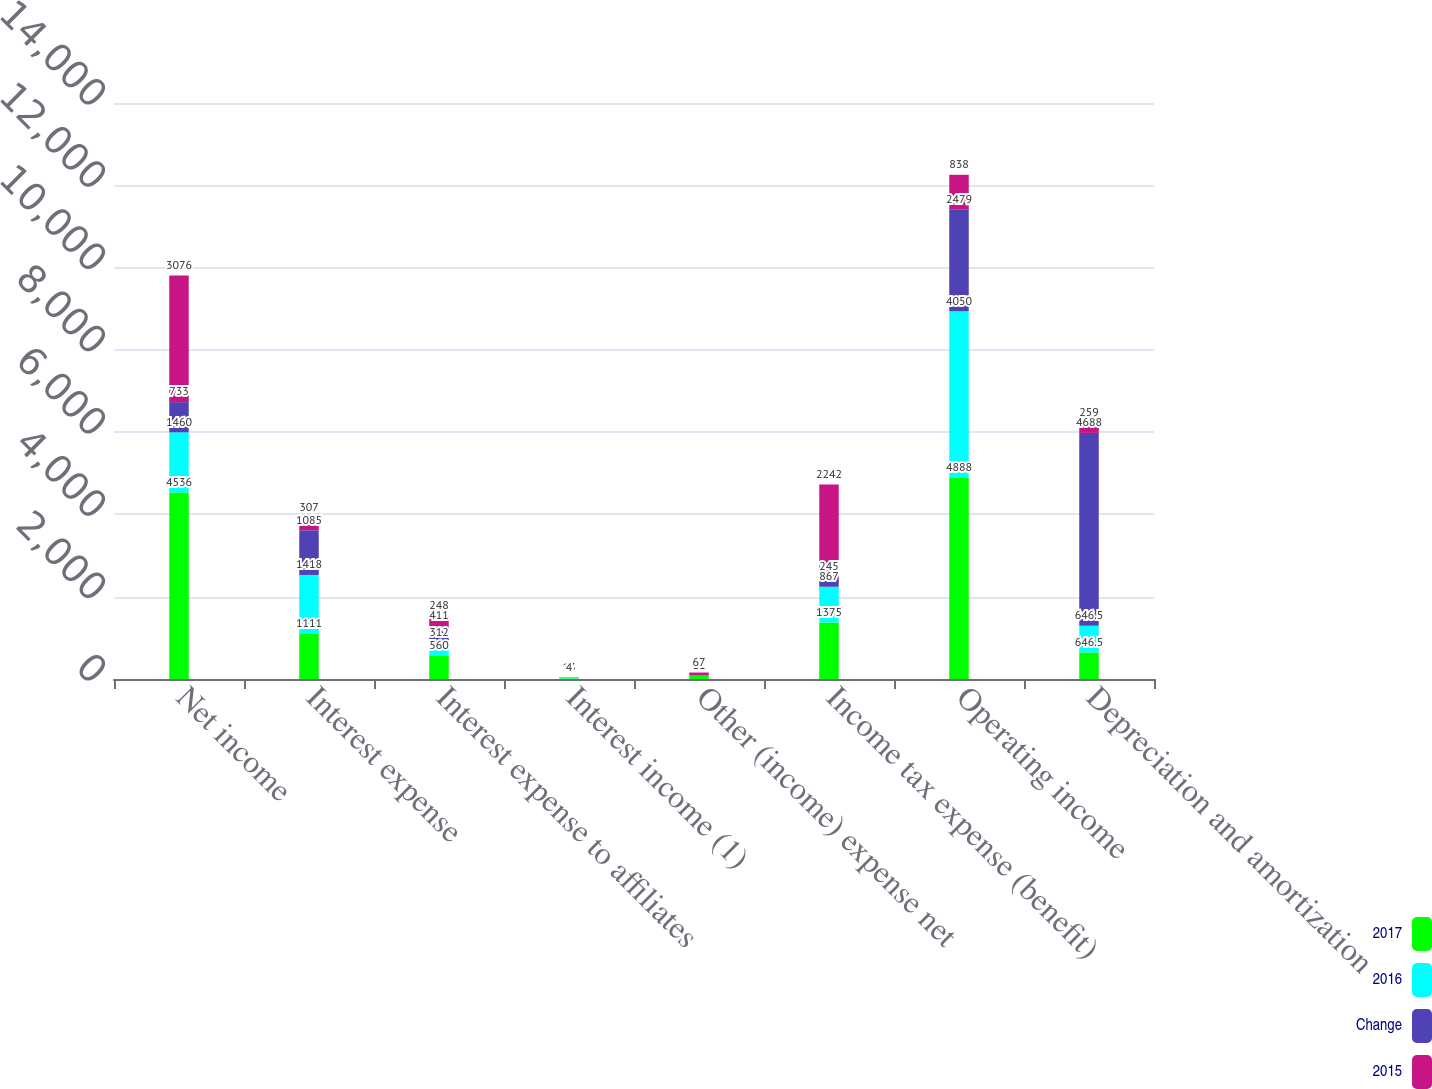<chart> <loc_0><loc_0><loc_500><loc_500><stacked_bar_chart><ecel><fcel>Net income<fcel>Interest expense<fcel>Interest expense to affiliates<fcel>Interest income (1)<fcel>Other (income) expense net<fcel>Income tax expense (benefit)<fcel>Operating income<fcel>Depreciation and amortization<nl><fcel>2017<fcel>4536<fcel>1111<fcel>560<fcel>17<fcel>73<fcel>1375<fcel>4888<fcel>646.5<nl><fcel>2016<fcel>1460<fcel>1418<fcel>312<fcel>13<fcel>6<fcel>867<fcel>4050<fcel>646.5<nl><fcel>Change<fcel>733<fcel>1085<fcel>411<fcel>6<fcel>11<fcel>245<fcel>2479<fcel>4688<nl><fcel>2015<fcel>3076<fcel>307<fcel>248<fcel>4<fcel>67<fcel>2242<fcel>838<fcel>259<nl></chart> 